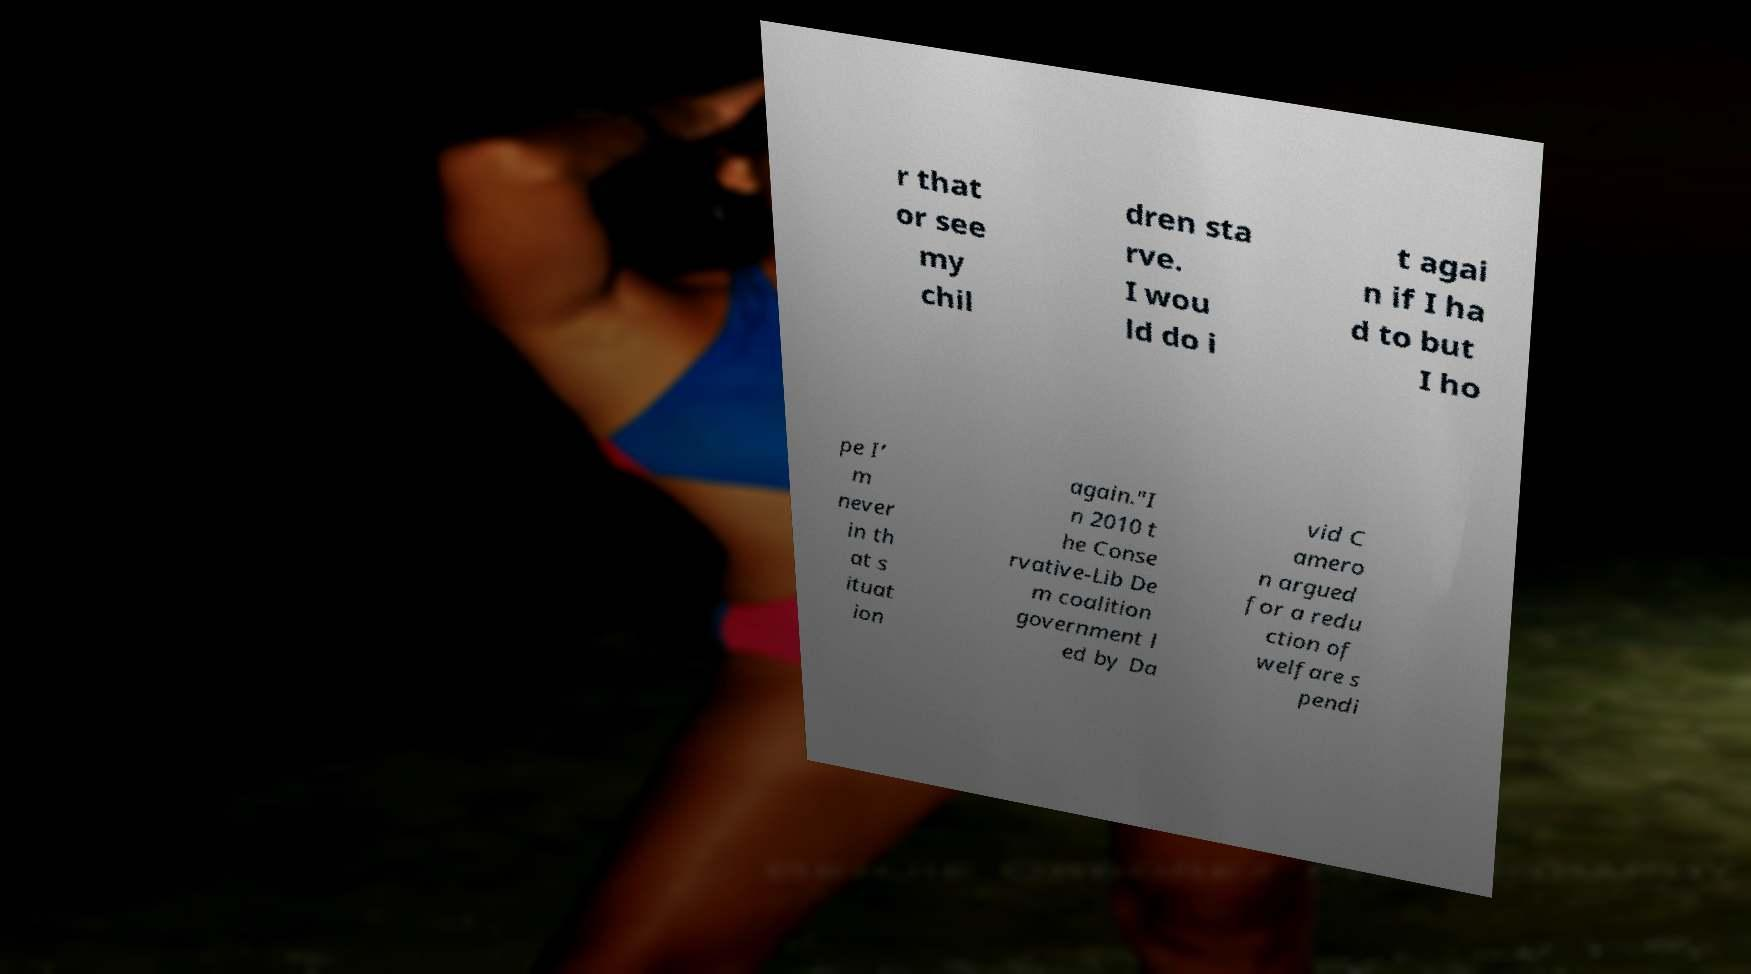Please read and relay the text visible in this image. What does it say? r that or see my chil dren sta rve. I wou ld do i t agai n if I ha d to but I ho pe I’ m never in th at s ituat ion again."I n 2010 t he Conse rvative-Lib De m coalition government l ed by Da vid C amero n argued for a redu ction of welfare s pendi 